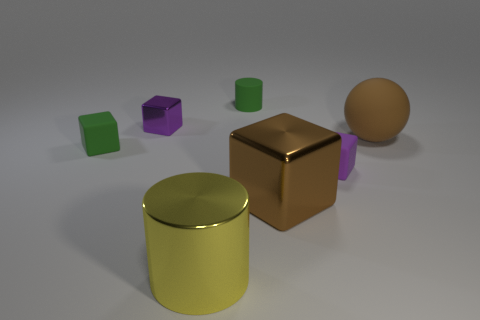Subtract all purple spheres. How many purple blocks are left? 2 Subtract all brown blocks. How many blocks are left? 3 Subtract 2 blocks. How many blocks are left? 2 Add 2 tiny yellow metallic cylinders. How many objects exist? 9 Subtract all small blocks. How many blocks are left? 1 Subtract all red blocks. Subtract all blue cylinders. How many blocks are left? 4 Subtract all spheres. How many objects are left? 6 Subtract 1 yellow cylinders. How many objects are left? 6 Subtract all rubber cylinders. Subtract all big yellow shiny objects. How many objects are left? 5 Add 4 big metallic cylinders. How many big metallic cylinders are left? 5 